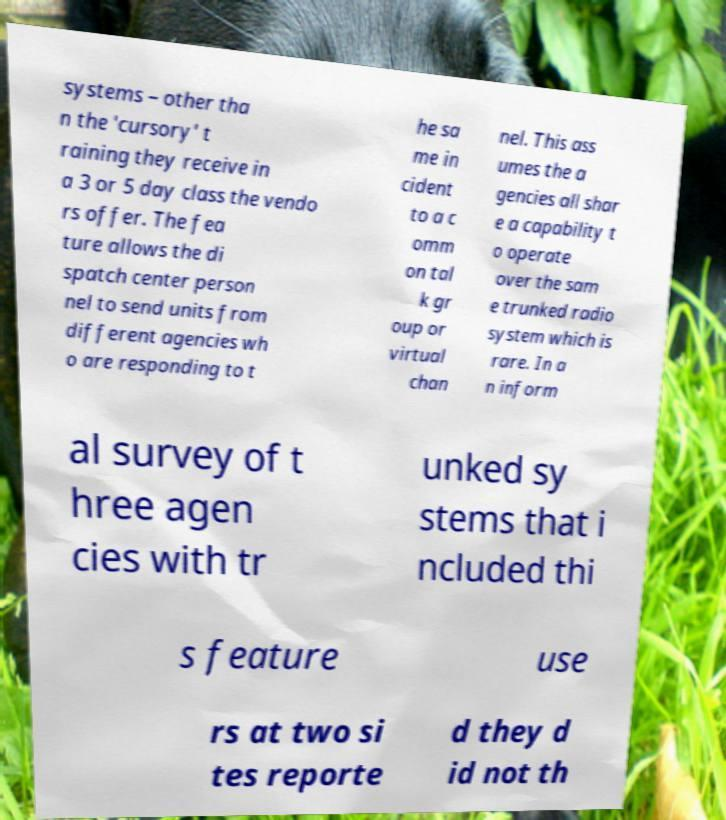Can you read and provide the text displayed in the image?This photo seems to have some interesting text. Can you extract and type it out for me? systems – other tha n the 'cursory' t raining they receive in a 3 or 5 day class the vendo rs offer. The fea ture allows the di spatch center person nel to send units from different agencies wh o are responding to t he sa me in cident to a c omm on tal k gr oup or virtual chan nel. This ass umes the a gencies all shar e a capability t o operate over the sam e trunked radio system which is rare. In a n inform al survey of t hree agen cies with tr unked sy stems that i ncluded thi s feature use rs at two si tes reporte d they d id not th 